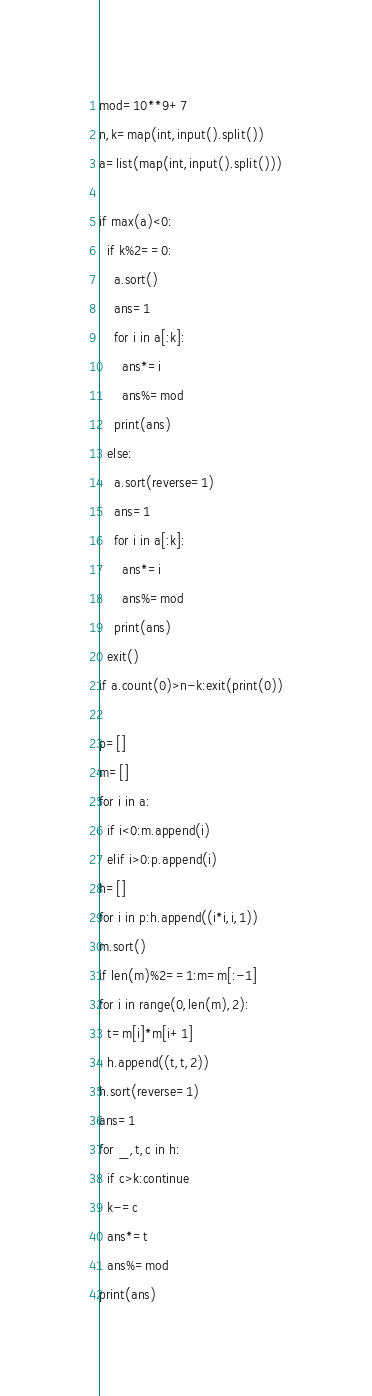Convert code to text. <code><loc_0><loc_0><loc_500><loc_500><_Python_>mod=10**9+7
n,k=map(int,input().split())
a=list(map(int,input().split()))

if max(a)<0:
  if k%2==0:
    a.sort()
    ans=1
    for i in a[:k]:
      ans*=i
      ans%=mod
    print(ans)
  else:
    a.sort(reverse=1)
    ans=1
    for i in a[:k]:
      ans*=i
      ans%=mod
    print(ans)
  exit()
if a.count(0)>n-k:exit(print(0))

p=[]
m=[]
for i in a:
  if i<0:m.append(i)
  elif i>0:p.append(i)
h=[]
for i in p:h.append((i*i,i,1))
m.sort()
if len(m)%2==1:m=m[:-1]
for i in range(0,len(m),2):
  t=m[i]*m[i+1]
  h.append((t,t,2))
h.sort(reverse=1)
ans=1
for _,t,c in h:
  if c>k:continue
  k-=c
  ans*=t
  ans%=mod
print(ans)
</code> 